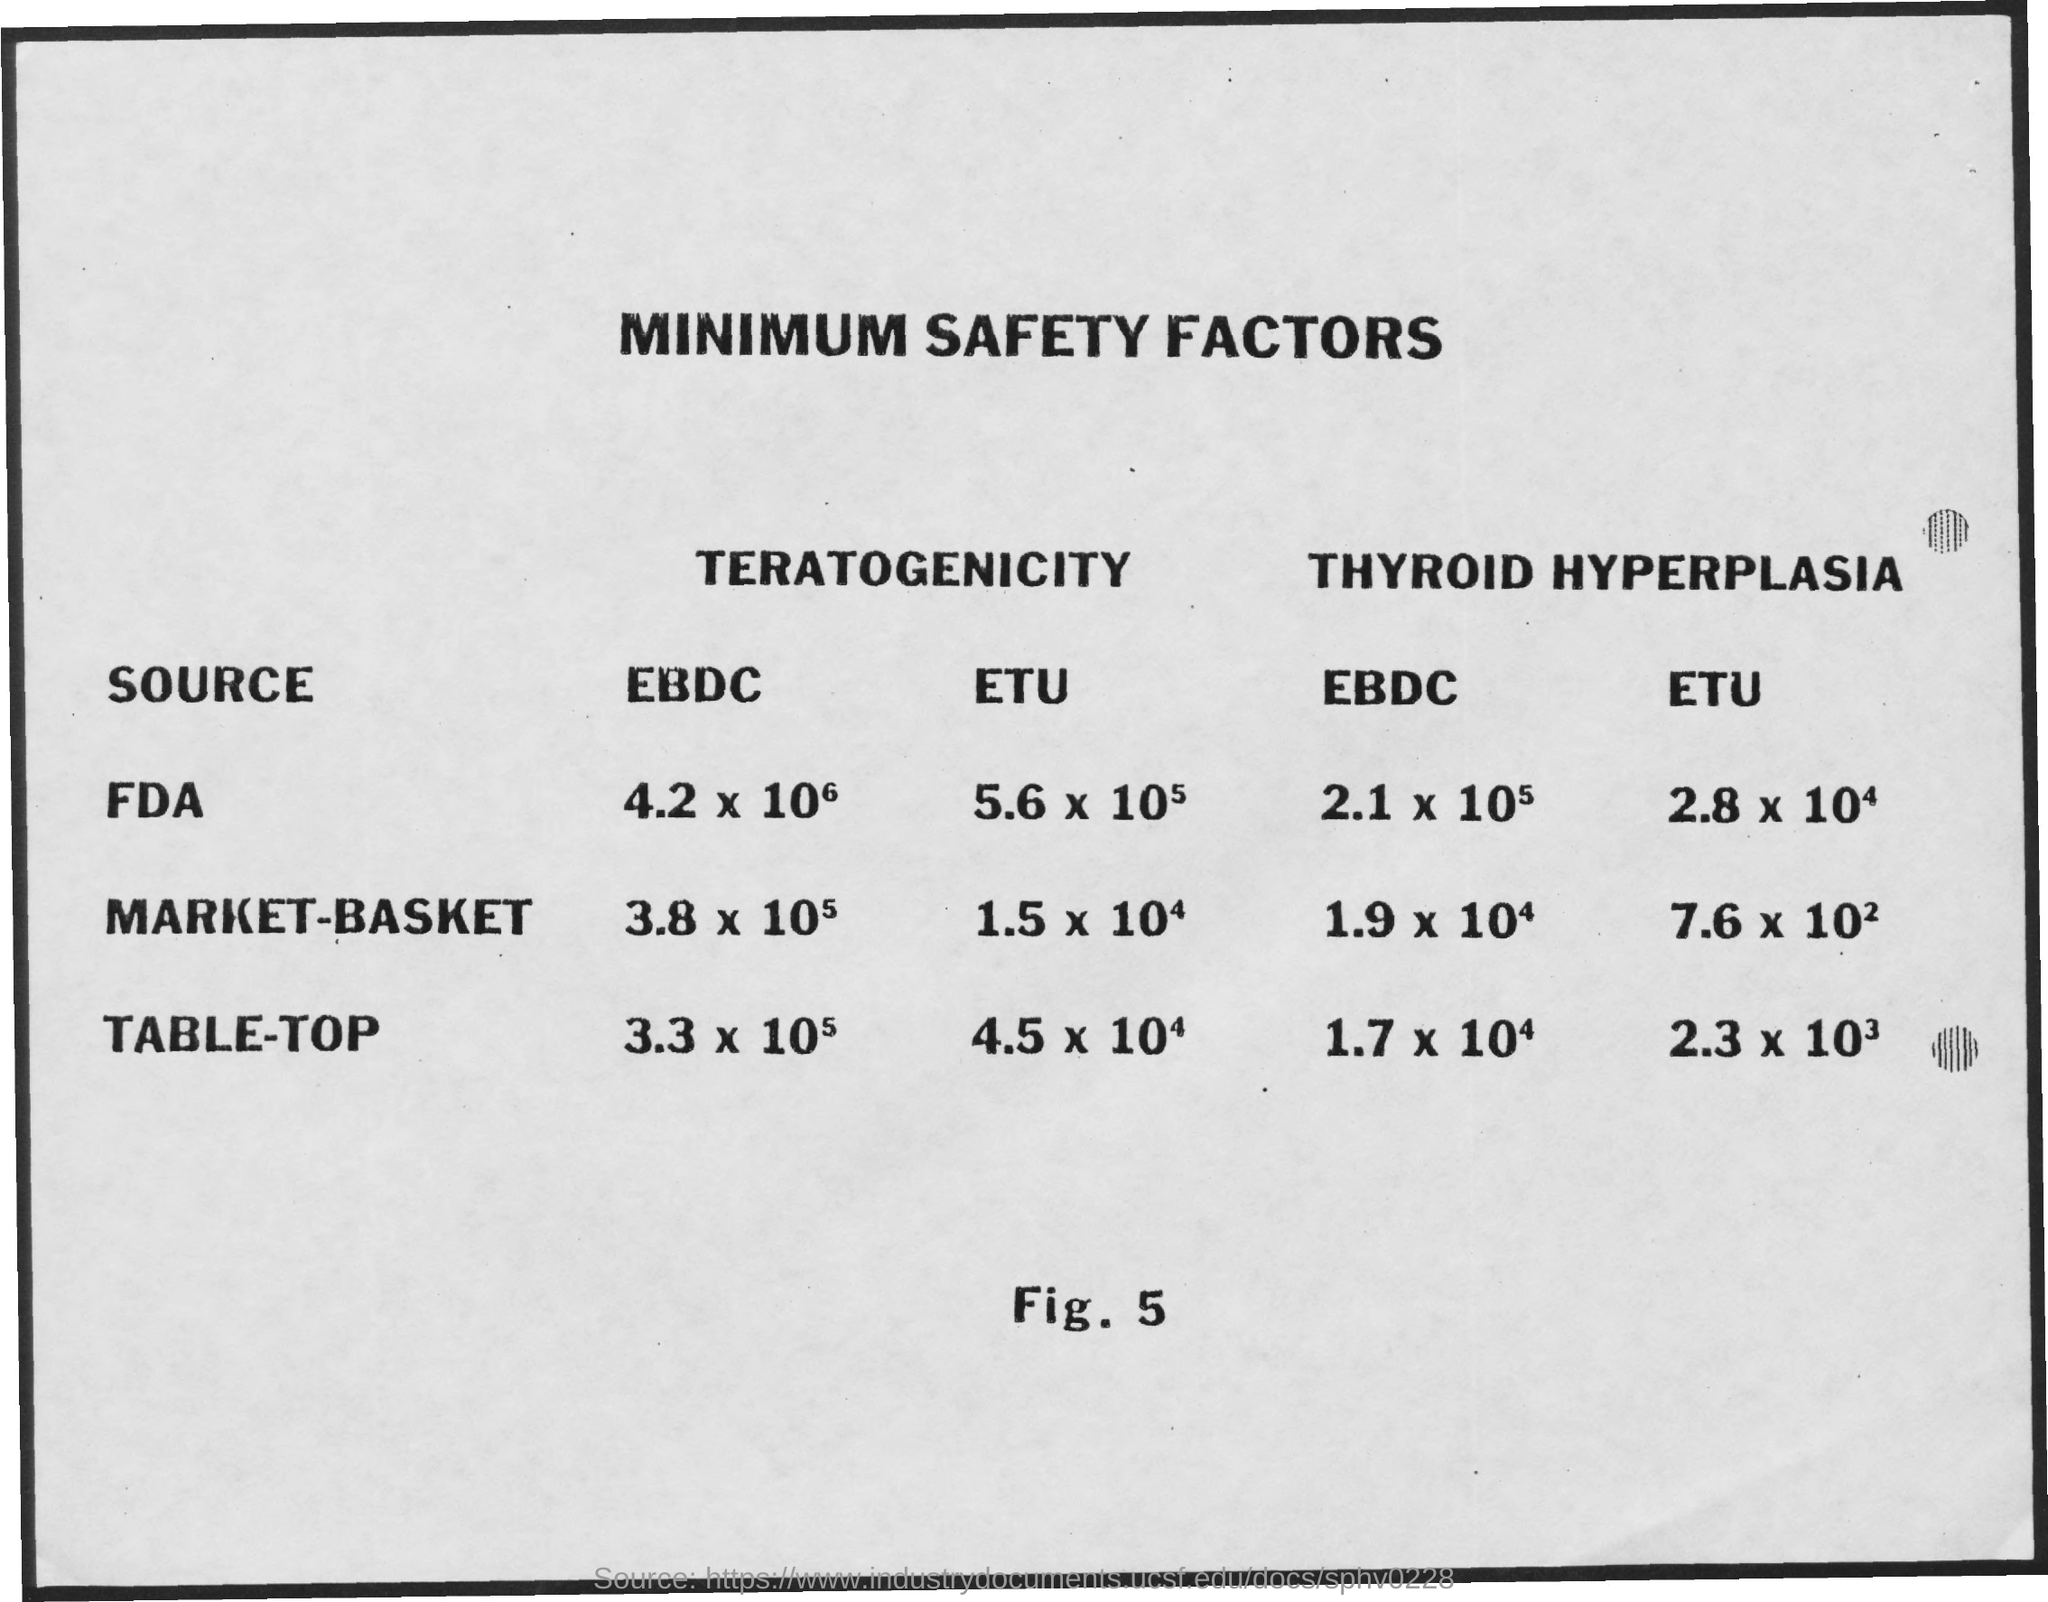Outline some significant characteristics in this image. The title of the document is 'Minimum Safety Factors.' 